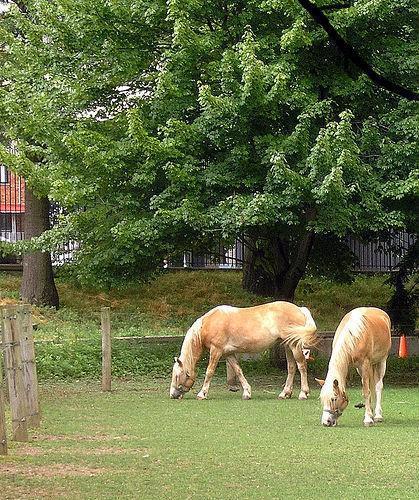How many horses are there?
Give a very brief answer. 2. How many people are wearing a blue wig?
Give a very brief answer. 0. 